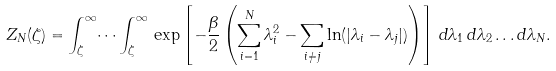<formula> <loc_0><loc_0><loc_500><loc_500>Z _ { N } ( \zeta ) = \int _ { \zeta } ^ { \infty } \dots \int _ { \zeta } ^ { \infty } \, \exp \left [ - \frac { \beta } { 2 } \left ( \sum _ { i = 1 } ^ { N } \lambda _ { i } ^ { 2 } - \sum _ { i \ne j } \ln ( | \lambda _ { i } - \lambda _ { j } | ) \right ) \right ] \, d \lambda _ { 1 } \, d \lambda _ { 2 } \dots d \lambda _ { N } .</formula> 